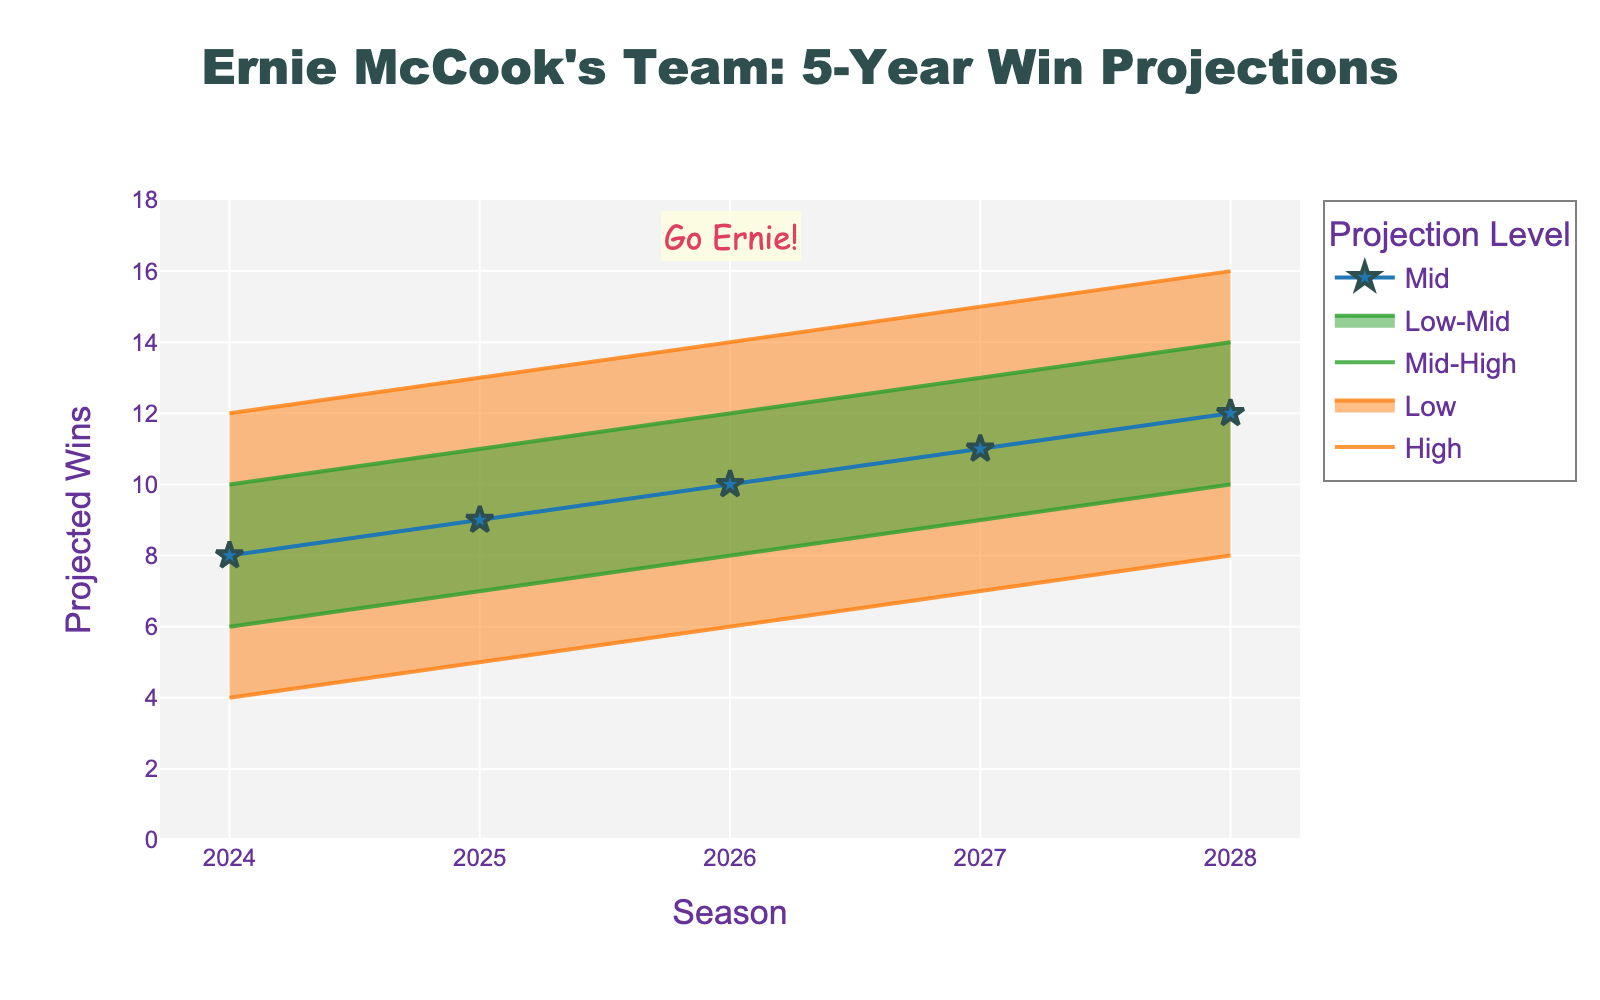What is the title of the figure? The title is displayed at the top of the chart. It reads "Ernie McCook's Team: 5-Year Win Projections."
Answer: Ernie McCook's Team: 5-Year Win Projections How many seasons are projected in this chart? Each season is marked on the x-axis from 2024 to 2028, meaning there are 5 seasons projected.
Answer: 5 What is the range of projected wins for the 2024 season? The chart shows the projected wins for 2024 between the Low and High bands, which are 4 and 12 respectively.
Answer: 4 to 12 Which season shows the highest 'Mid' projection? By looking at the 'Mid' line (blue line with star markers), the highest value is for the 2028 season at 12 wins.
Answer: 2028 What is the difference in the 'Low' projections between 2024 and 2028? The 'Low' projection for 2024 is 4, and for 2028 it is 8. The difference is 8 - 4 = 4 wins.
Answer: 4 wins Which projection level has the widest range for the 2025 season? For 2025, the difference between 'High' (13) and 'Low' (5) is 8 wins, and the difference between 'Mid-High' (11) and 'Low-Mid' (7) is 4 wins. 'High' and 'Low' have the widest range.
Answer: High and Low How does the projected range (High-Low) change from 2024 to 2028? For 2024, the range is 12 - 4 = 8 wins. For 2028, it is 16 - 8 = 8 wins. The range remains the same at 8 wins.
Answer: Remains the same Which season has the smallest difference between 'Mid' and 'High' projections? The difference for each season can be calculated: 
2024: 12 - 8 = 4,
2025: 13 - 9 = 4,
2026: 14 - 10 = 4,
2027: 15 - 11 = 4,
2028: 16 - 12 = 4.
All seasons have the same difference of 4 wins.
Answer: All seasons What are the color codes of the 'Mid-High' and 'Low-Mid' projection lines? The chart shows 'Mid-High' in green and 'Low-Mid' also in green but slightly transparent.
Answer: Green (both) What annotation is added to the chart? There is a text annotation "Go Ernie!" positioned near the 2026 season, highlighted in LightYellow with Crimson text.
Answer: Go Ernie! 